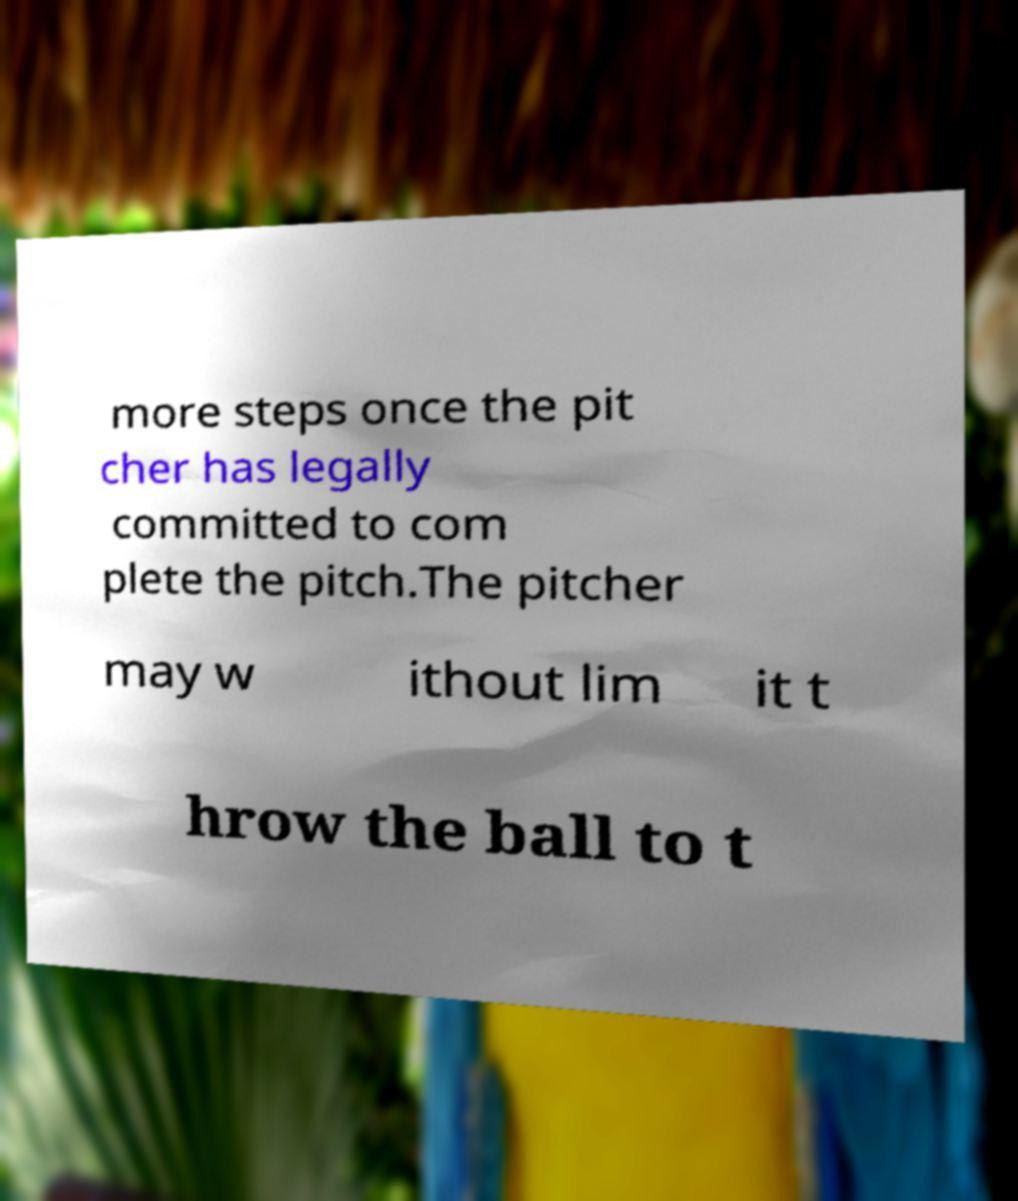There's text embedded in this image that I need extracted. Can you transcribe it verbatim? more steps once the pit cher has legally committed to com plete the pitch.The pitcher may w ithout lim it t hrow the ball to t 